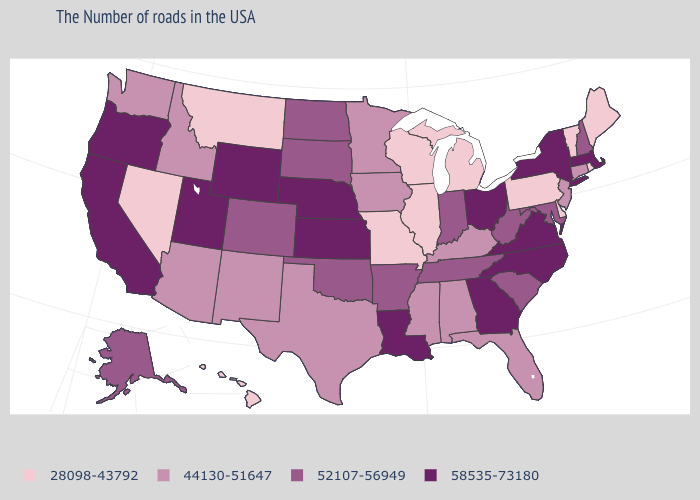Name the states that have a value in the range 58535-73180?
Write a very short answer. Massachusetts, New York, Virginia, North Carolina, Ohio, Georgia, Louisiana, Kansas, Nebraska, Wyoming, Utah, California, Oregon. Name the states that have a value in the range 28098-43792?
Answer briefly. Maine, Rhode Island, Vermont, Delaware, Pennsylvania, Michigan, Wisconsin, Illinois, Missouri, Montana, Nevada, Hawaii. Which states have the highest value in the USA?
Keep it brief. Massachusetts, New York, Virginia, North Carolina, Ohio, Georgia, Louisiana, Kansas, Nebraska, Wyoming, Utah, California, Oregon. What is the value of Pennsylvania?
Quick response, please. 28098-43792. What is the value of Nebraska?
Give a very brief answer. 58535-73180. Among the states that border North Dakota , which have the highest value?
Keep it brief. South Dakota. Name the states that have a value in the range 58535-73180?
Give a very brief answer. Massachusetts, New York, Virginia, North Carolina, Ohio, Georgia, Louisiana, Kansas, Nebraska, Wyoming, Utah, California, Oregon. What is the value of Arkansas?
Concise answer only. 52107-56949. What is the value of Vermont?
Keep it brief. 28098-43792. Does Connecticut have a higher value than Hawaii?
Write a very short answer. Yes. Among the states that border New Hampshire , which have the highest value?
Give a very brief answer. Massachusetts. What is the lowest value in states that border Colorado?
Concise answer only. 44130-51647. Does Wyoming have the highest value in the USA?
Give a very brief answer. Yes. What is the lowest value in the West?
Be succinct. 28098-43792. 